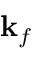Convert formula to latex. <formula><loc_0><loc_0><loc_500><loc_500>{ k } _ { f }</formula> 